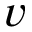<formula> <loc_0><loc_0><loc_500><loc_500>v</formula> 